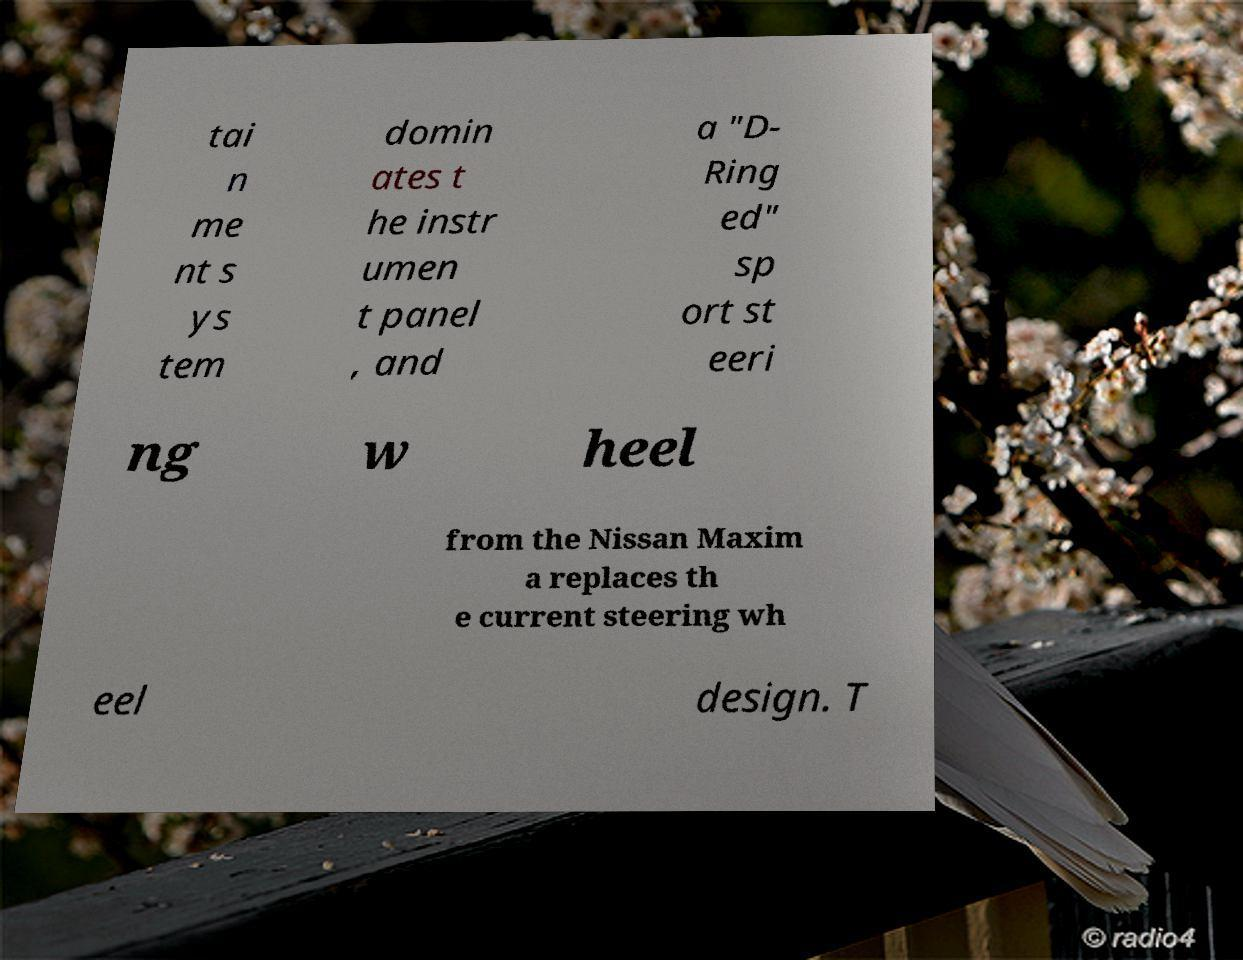Could you extract and type out the text from this image? tai n me nt s ys tem domin ates t he instr umen t panel , and a "D- Ring ed" sp ort st eeri ng w heel from the Nissan Maxim a replaces th e current steering wh eel design. T 